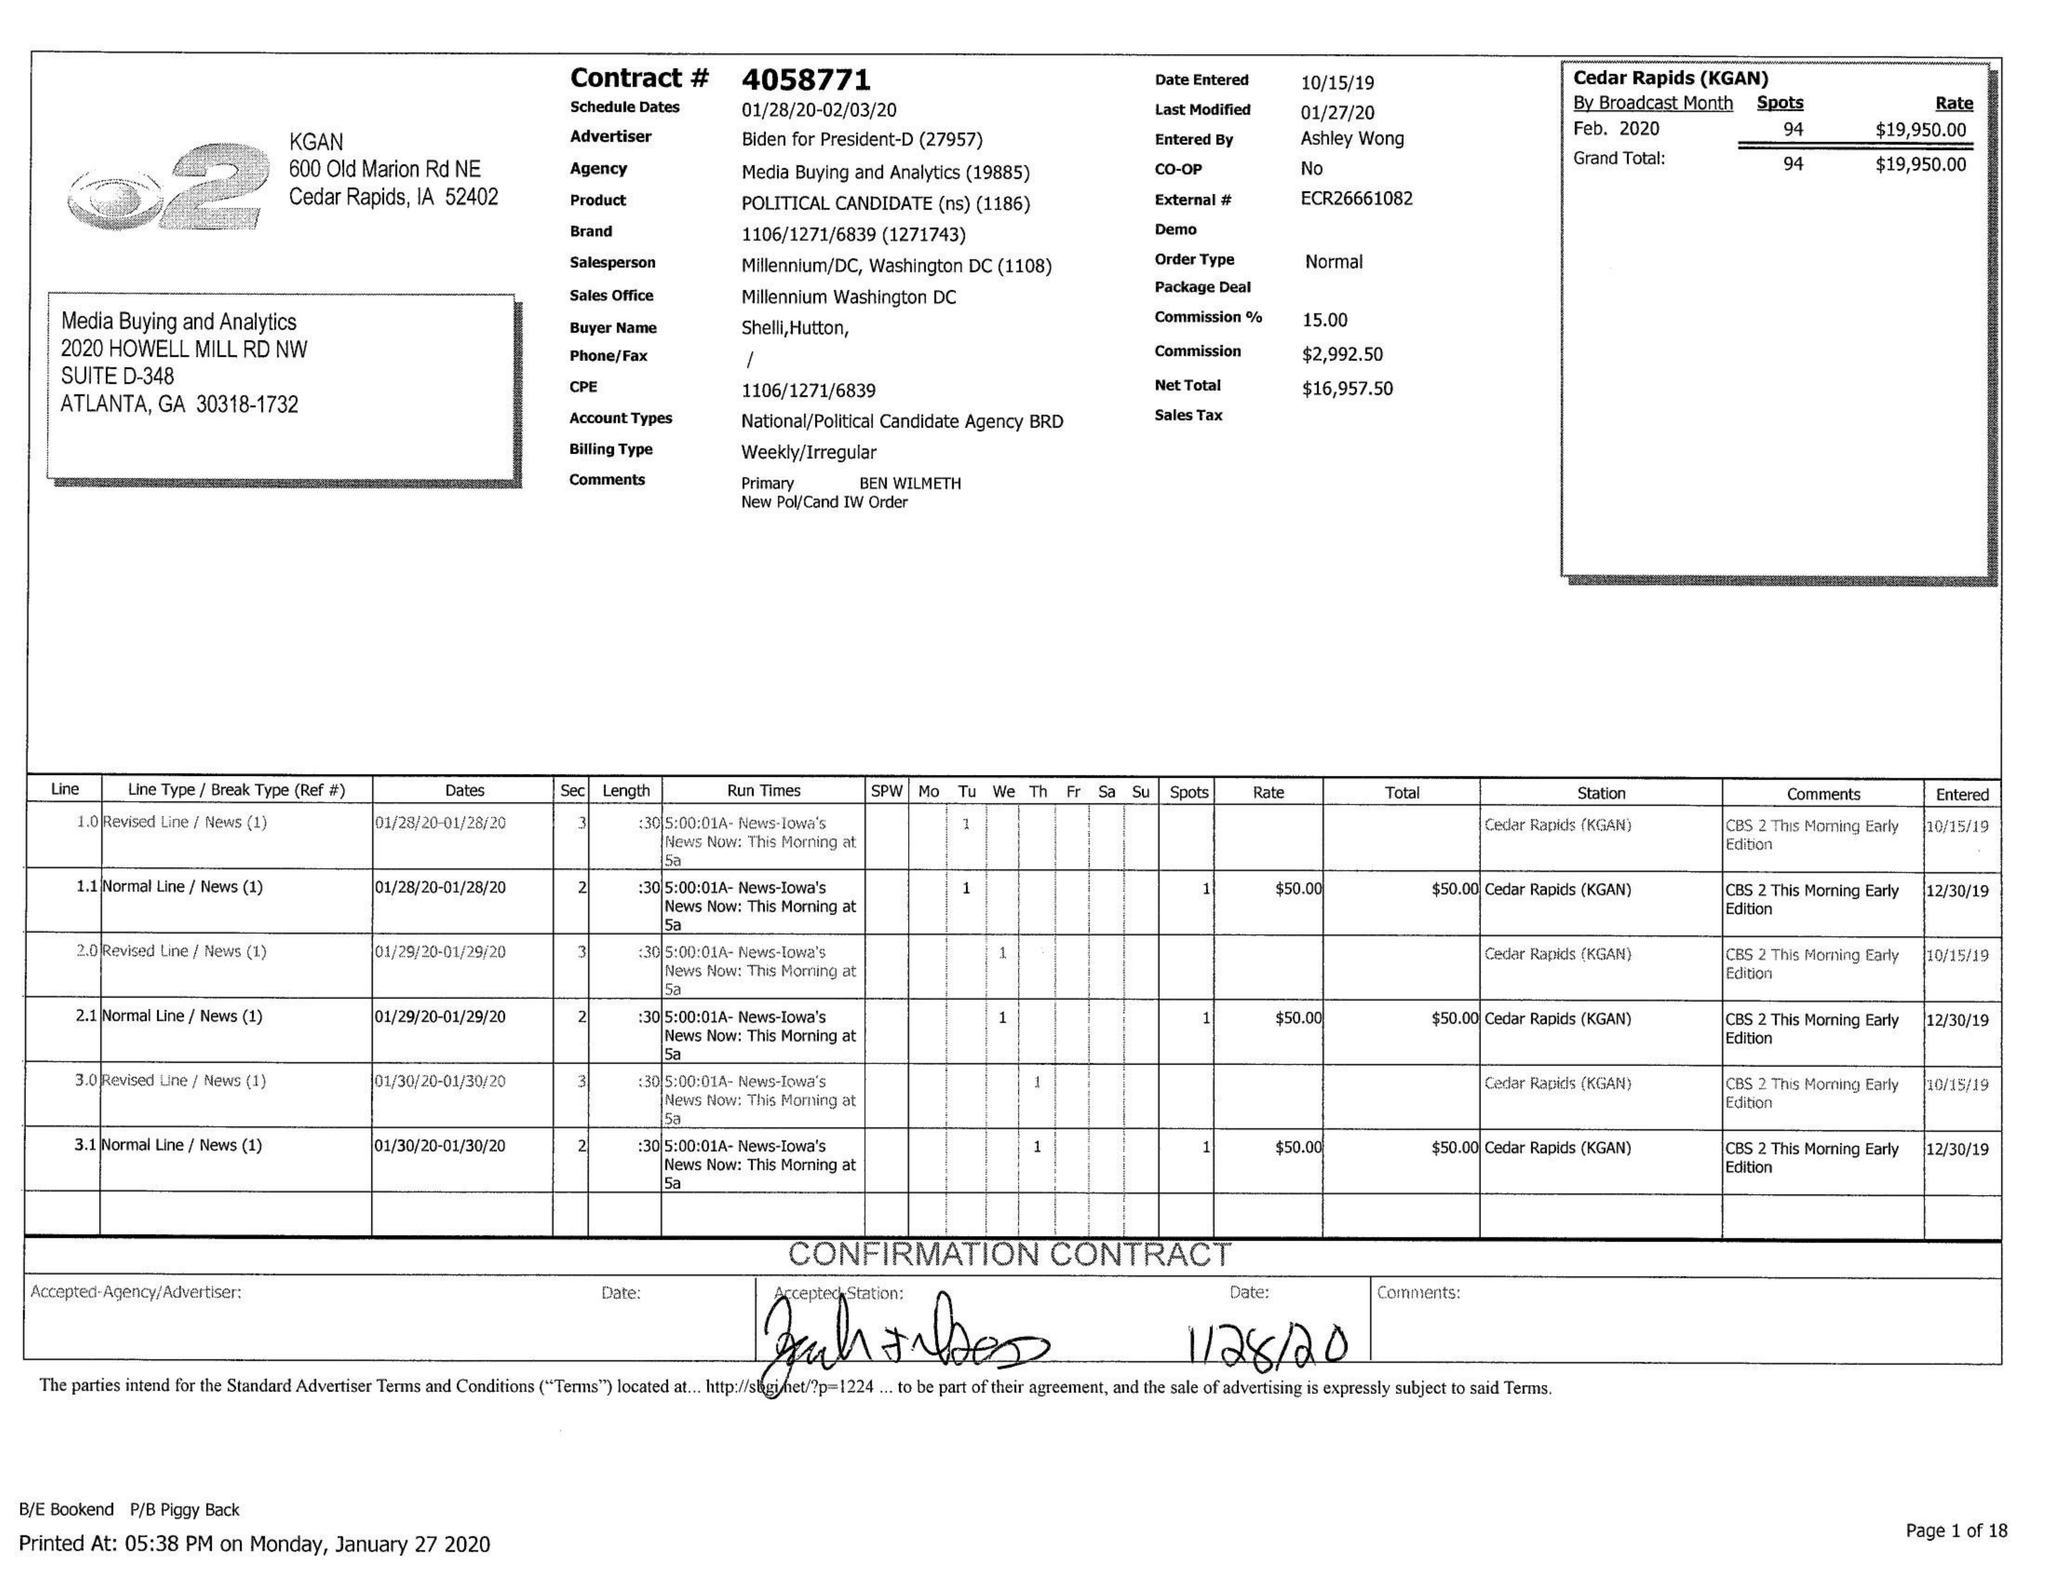What is the value for the advertiser?
Answer the question using a single word or phrase. BIDEN FOR PRESIDENT 